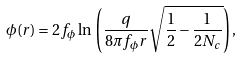Convert formula to latex. <formula><loc_0><loc_0><loc_500><loc_500>\phi ( r ) = 2 f _ { \phi } \ln \, \left ( \frac { q } { 8 \pi f _ { \phi } r } \sqrt { \frac { 1 } { 2 } - \frac { 1 } { 2 N _ { c } } } \right ) ,</formula> 